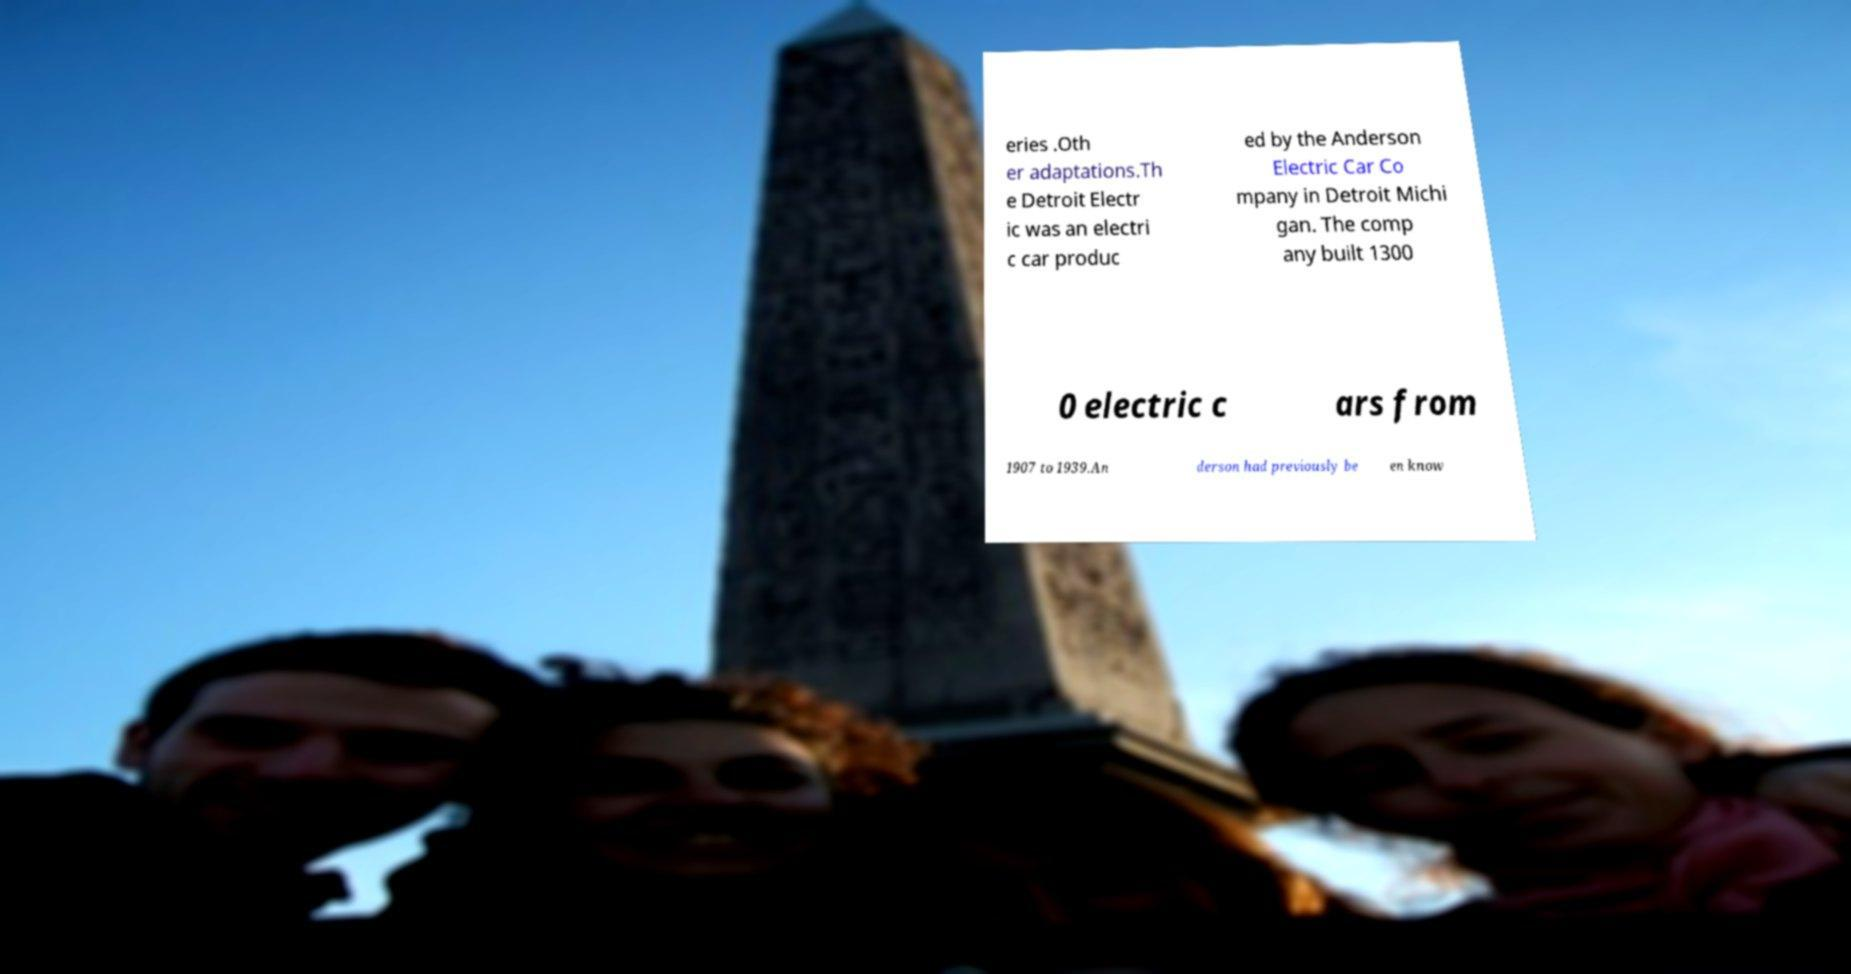There's text embedded in this image that I need extracted. Can you transcribe it verbatim? eries .Oth er adaptations.Th e Detroit Electr ic was an electri c car produc ed by the Anderson Electric Car Co mpany in Detroit Michi gan. The comp any built 1300 0 electric c ars from 1907 to 1939.An derson had previously be en know 